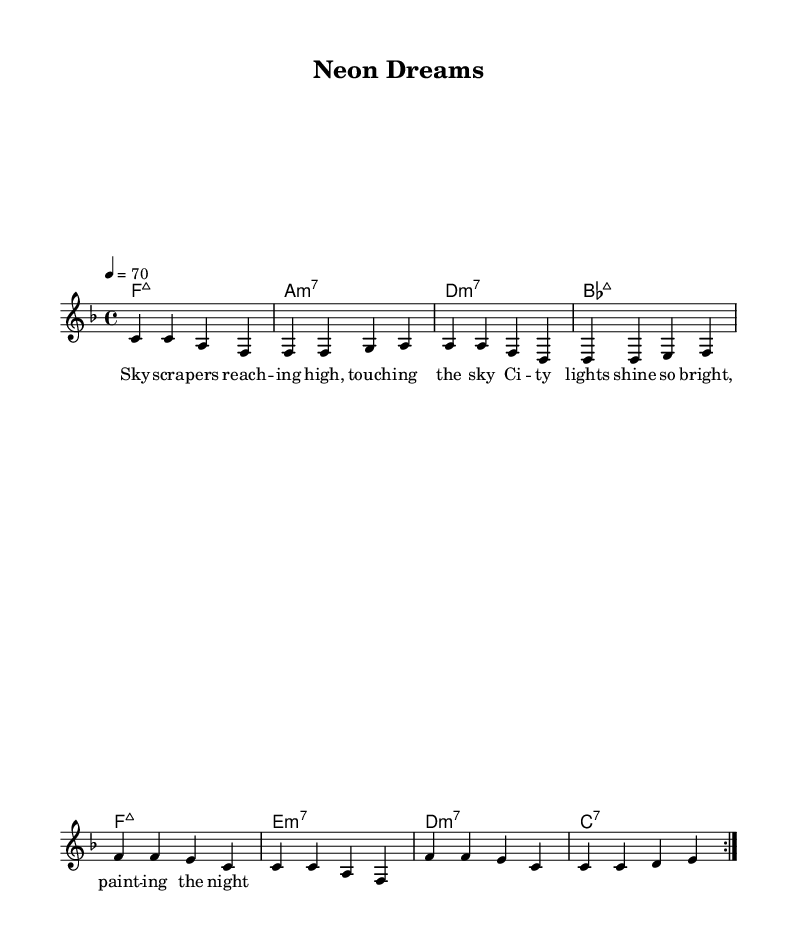What key is this music written in? The key signature is indicated at the beginning of the score, which shows one flat, representing F major.
Answer: F major What is the time signature of the music? The time signature is located next to the key signature at the start of the score, which shows a 4 over 4.
Answer: 4/4 What is the tempo marking for this piece? The tempo is indicated at the beginning of the score as "4 = 70", meaning there are 70 beats per minute when counting quarter notes.
Answer: 70 How many measures are in the repeated section? The repeated section consists of 8 measures total when combining both volta repeats, as indicated by the repeat signs.
Answer: 8 What type of chords are primarily used in the harmony section? The harmony section includes major seventh and minor seventh chords, which are commonly used in R&B music, as can be inferred from the chord names.
Answer: Major seventh and minor seventh What theme is conveyed in the lyrics of the song? The lyrics express admiration for the city lights and the beauty they bring to the night, highlighting a smooth urban atmosphere which is a common R&B theme.
Answer: City lights and night beauty What is the overall structure of the piece? The piece follows a verse structure with repeated sections, typical in R&B music, shown through the volta repeat markings in the score.
Answer: Verse structure with repeats 